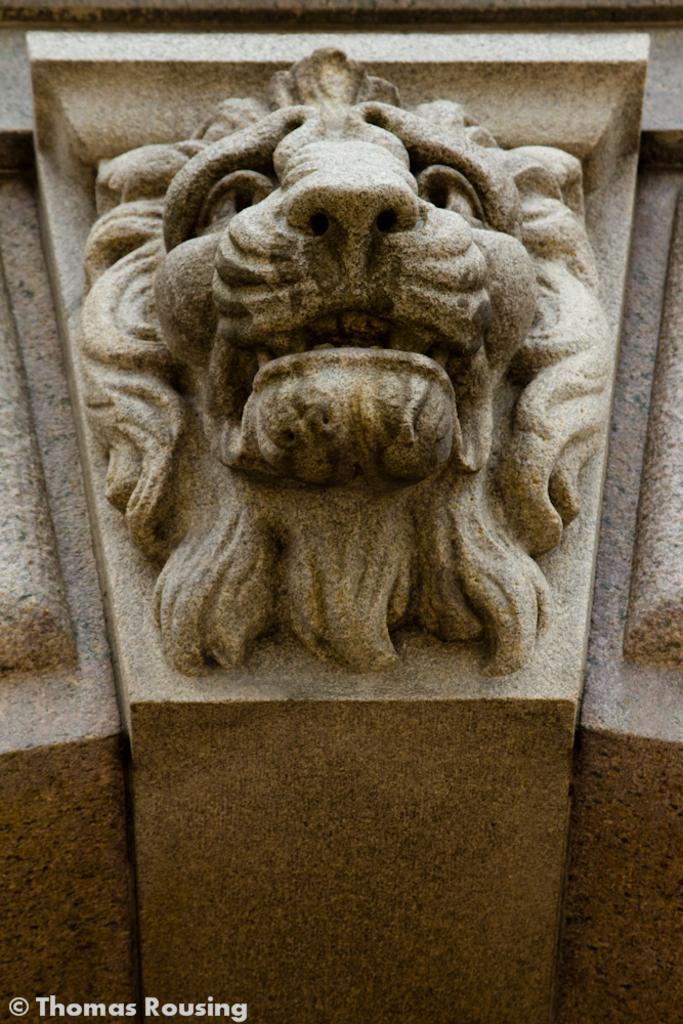In one or two sentences, can you explain what this image depicts? In this picture, we can see some carvings on the wall, and we can see watermark in the bottom left corner. 